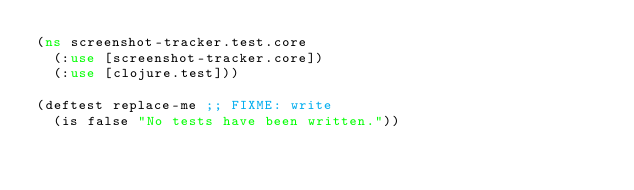<code> <loc_0><loc_0><loc_500><loc_500><_Clojure_>(ns screenshot-tracker.test.core
  (:use [screenshot-tracker.core])
  (:use [clojure.test]))

(deftest replace-me ;; FIXME: write
  (is false "No tests have been written."))
</code> 